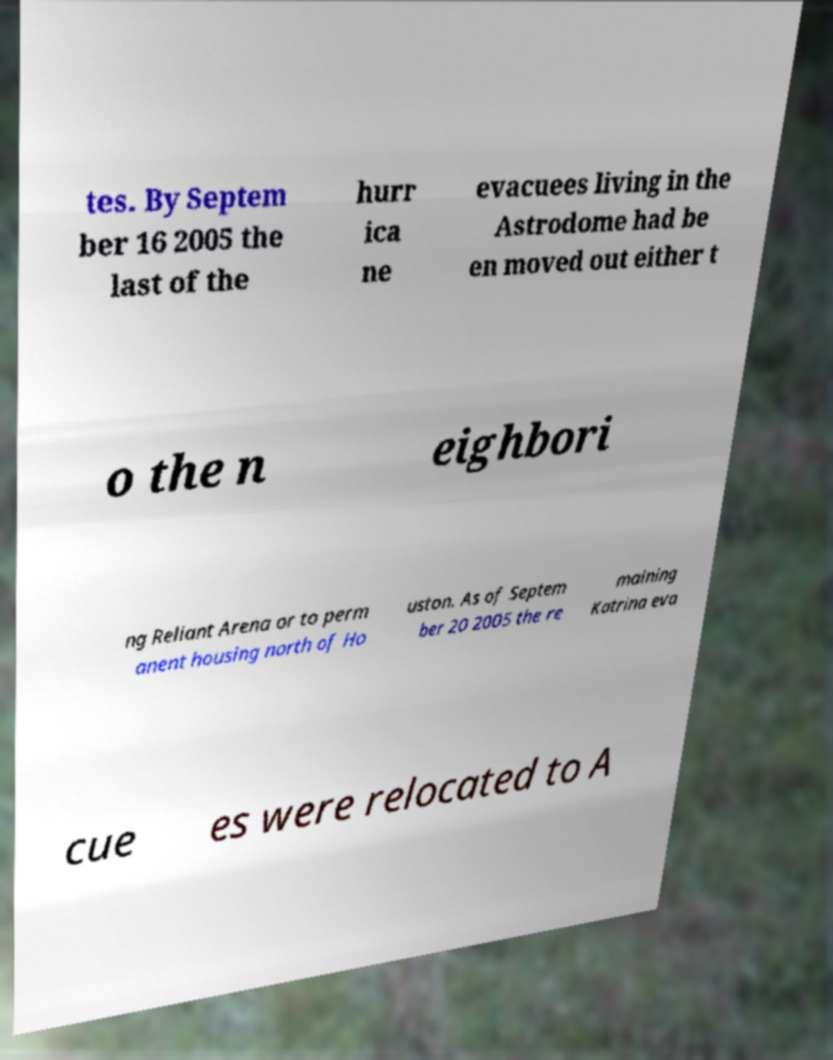Can you read and provide the text displayed in the image?This photo seems to have some interesting text. Can you extract and type it out for me? tes. By Septem ber 16 2005 the last of the hurr ica ne evacuees living in the Astrodome had be en moved out either t o the n eighbori ng Reliant Arena or to perm anent housing north of Ho uston. As of Septem ber 20 2005 the re maining Katrina eva cue es were relocated to A 